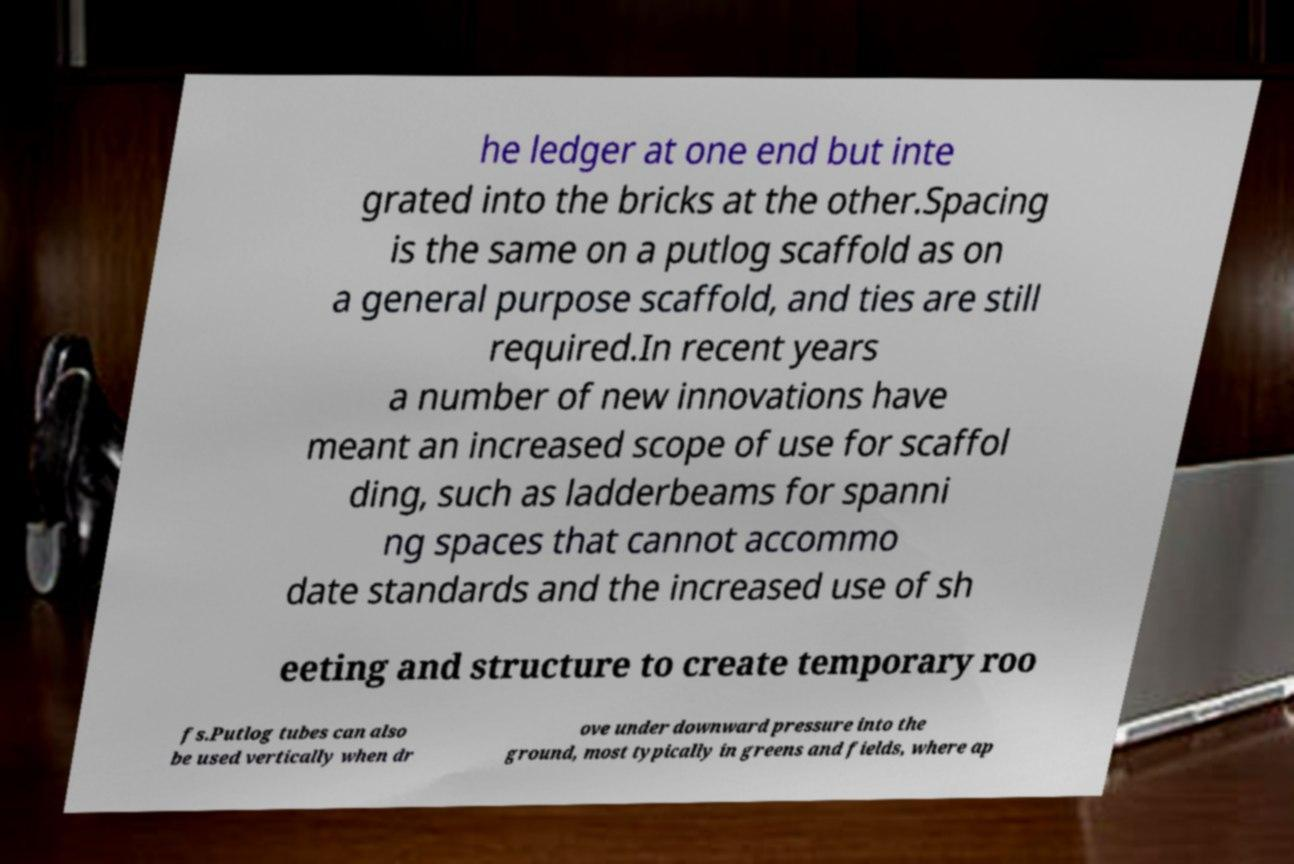Please identify and transcribe the text found in this image. he ledger at one end but inte grated into the bricks at the other.Spacing is the same on a putlog scaffold as on a general purpose scaffold, and ties are still required.In recent years a number of new innovations have meant an increased scope of use for scaffol ding, such as ladderbeams for spanni ng spaces that cannot accommo date standards and the increased use of sh eeting and structure to create temporary roo fs.Putlog tubes can also be used vertically when dr ove under downward pressure into the ground, most typically in greens and fields, where ap 